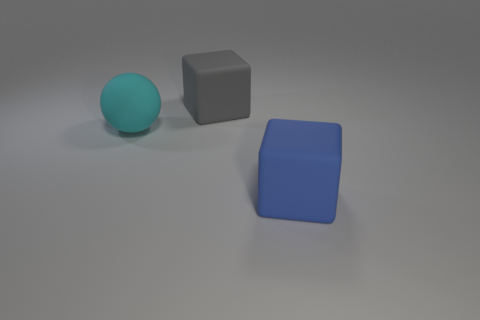Subtract all blue cubes. How many cubes are left? 1 Add 2 blue rubber blocks. How many objects exist? 5 Subtract all spheres. How many objects are left? 2 Subtract 0 red spheres. How many objects are left? 3 Subtract all large blue rubber blocks. Subtract all big rubber spheres. How many objects are left? 1 Add 3 blocks. How many blocks are left? 5 Add 1 balls. How many balls exist? 2 